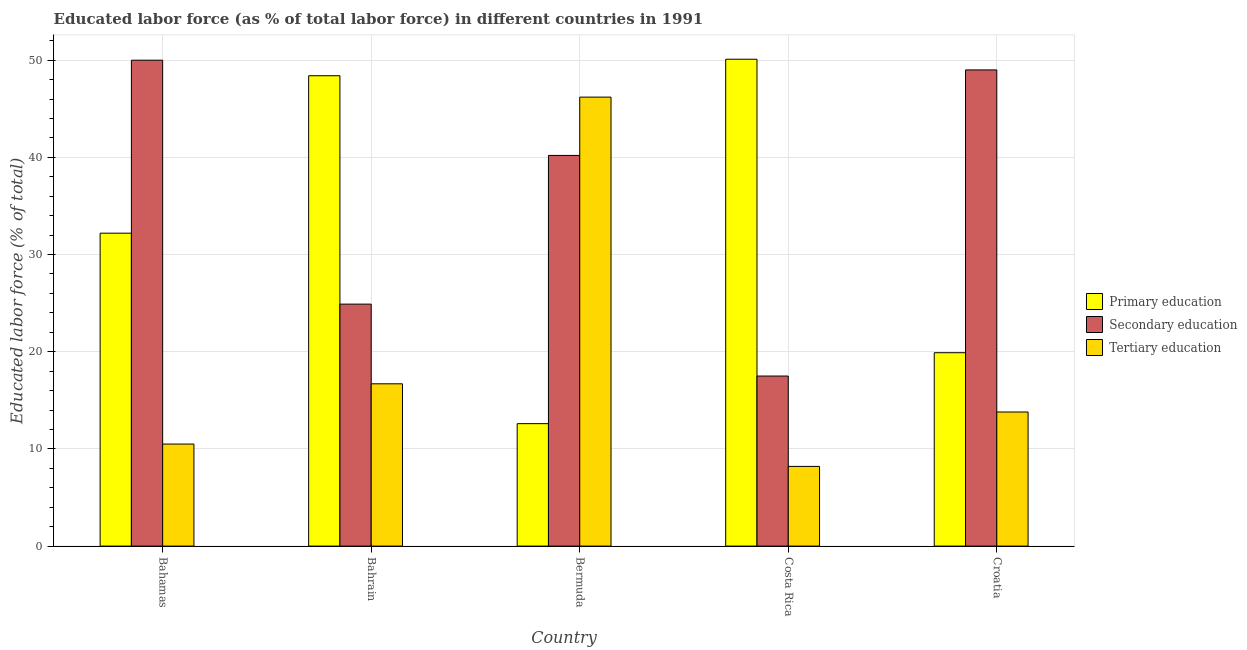How many groups of bars are there?
Ensure brevity in your answer.  5. Are the number of bars per tick equal to the number of legend labels?
Offer a very short reply. Yes. How many bars are there on the 1st tick from the left?
Offer a terse response. 3. What is the label of the 5th group of bars from the left?
Your answer should be compact. Croatia. In how many cases, is the number of bars for a given country not equal to the number of legend labels?
Make the answer very short. 0. What is the percentage of labor force who received primary education in Bahamas?
Your answer should be compact. 32.2. Across all countries, what is the maximum percentage of labor force who received primary education?
Provide a short and direct response. 50.1. Across all countries, what is the minimum percentage of labor force who received secondary education?
Keep it short and to the point. 17.5. In which country was the percentage of labor force who received tertiary education minimum?
Provide a succinct answer. Costa Rica. What is the total percentage of labor force who received secondary education in the graph?
Ensure brevity in your answer.  181.6. What is the difference between the percentage of labor force who received tertiary education in Bahamas and that in Bahrain?
Offer a very short reply. -6.2. What is the difference between the percentage of labor force who received secondary education in Croatia and the percentage of labor force who received primary education in Costa Rica?
Offer a very short reply. -1.1. What is the average percentage of labor force who received tertiary education per country?
Your answer should be compact. 19.08. What is the difference between the percentage of labor force who received tertiary education and percentage of labor force who received secondary education in Bahrain?
Your response must be concise. -8.2. In how many countries, is the percentage of labor force who received primary education greater than 18 %?
Your response must be concise. 4. What is the ratio of the percentage of labor force who received secondary education in Bermuda to that in Costa Rica?
Your response must be concise. 2.3. Is the percentage of labor force who received secondary education in Costa Rica less than that in Croatia?
Keep it short and to the point. Yes. What is the difference between the highest and the second highest percentage of labor force who received primary education?
Keep it short and to the point. 1.7. What is the difference between the highest and the lowest percentage of labor force who received primary education?
Provide a short and direct response. 37.5. In how many countries, is the percentage of labor force who received tertiary education greater than the average percentage of labor force who received tertiary education taken over all countries?
Your response must be concise. 1. Is the sum of the percentage of labor force who received tertiary education in Costa Rica and Croatia greater than the maximum percentage of labor force who received secondary education across all countries?
Offer a terse response. No. What does the 3rd bar from the left in Bermuda represents?
Your response must be concise. Tertiary education. What does the 3rd bar from the right in Bermuda represents?
Make the answer very short. Primary education. How many countries are there in the graph?
Give a very brief answer. 5. What is the difference between two consecutive major ticks on the Y-axis?
Give a very brief answer. 10. Does the graph contain any zero values?
Offer a terse response. No. Where does the legend appear in the graph?
Offer a very short reply. Center right. How many legend labels are there?
Your answer should be compact. 3. How are the legend labels stacked?
Provide a short and direct response. Vertical. What is the title of the graph?
Provide a succinct answer. Educated labor force (as % of total labor force) in different countries in 1991. What is the label or title of the X-axis?
Keep it short and to the point. Country. What is the label or title of the Y-axis?
Offer a very short reply. Educated labor force (% of total). What is the Educated labor force (% of total) in Primary education in Bahamas?
Keep it short and to the point. 32.2. What is the Educated labor force (% of total) of Tertiary education in Bahamas?
Make the answer very short. 10.5. What is the Educated labor force (% of total) of Primary education in Bahrain?
Provide a short and direct response. 48.4. What is the Educated labor force (% of total) of Secondary education in Bahrain?
Offer a very short reply. 24.9. What is the Educated labor force (% of total) in Tertiary education in Bahrain?
Ensure brevity in your answer.  16.7. What is the Educated labor force (% of total) of Primary education in Bermuda?
Provide a short and direct response. 12.6. What is the Educated labor force (% of total) of Secondary education in Bermuda?
Your answer should be compact. 40.2. What is the Educated labor force (% of total) of Tertiary education in Bermuda?
Provide a short and direct response. 46.2. What is the Educated labor force (% of total) of Primary education in Costa Rica?
Give a very brief answer. 50.1. What is the Educated labor force (% of total) in Secondary education in Costa Rica?
Provide a short and direct response. 17.5. What is the Educated labor force (% of total) in Tertiary education in Costa Rica?
Offer a very short reply. 8.2. What is the Educated labor force (% of total) in Primary education in Croatia?
Your answer should be very brief. 19.9. What is the Educated labor force (% of total) of Secondary education in Croatia?
Your answer should be very brief. 49. What is the Educated labor force (% of total) in Tertiary education in Croatia?
Provide a succinct answer. 13.8. Across all countries, what is the maximum Educated labor force (% of total) of Primary education?
Offer a terse response. 50.1. Across all countries, what is the maximum Educated labor force (% of total) in Tertiary education?
Make the answer very short. 46.2. Across all countries, what is the minimum Educated labor force (% of total) in Primary education?
Keep it short and to the point. 12.6. Across all countries, what is the minimum Educated labor force (% of total) of Tertiary education?
Your response must be concise. 8.2. What is the total Educated labor force (% of total) of Primary education in the graph?
Provide a succinct answer. 163.2. What is the total Educated labor force (% of total) of Secondary education in the graph?
Offer a very short reply. 181.6. What is the total Educated labor force (% of total) in Tertiary education in the graph?
Offer a very short reply. 95.4. What is the difference between the Educated labor force (% of total) in Primary education in Bahamas and that in Bahrain?
Keep it short and to the point. -16.2. What is the difference between the Educated labor force (% of total) of Secondary education in Bahamas and that in Bahrain?
Provide a short and direct response. 25.1. What is the difference between the Educated labor force (% of total) of Tertiary education in Bahamas and that in Bahrain?
Offer a terse response. -6.2. What is the difference between the Educated labor force (% of total) of Primary education in Bahamas and that in Bermuda?
Your answer should be very brief. 19.6. What is the difference between the Educated labor force (% of total) in Tertiary education in Bahamas and that in Bermuda?
Your answer should be very brief. -35.7. What is the difference between the Educated labor force (% of total) of Primary education in Bahamas and that in Costa Rica?
Provide a short and direct response. -17.9. What is the difference between the Educated labor force (% of total) of Secondary education in Bahamas and that in Costa Rica?
Your response must be concise. 32.5. What is the difference between the Educated labor force (% of total) of Tertiary education in Bahamas and that in Costa Rica?
Ensure brevity in your answer.  2.3. What is the difference between the Educated labor force (% of total) in Primary education in Bahamas and that in Croatia?
Your answer should be compact. 12.3. What is the difference between the Educated labor force (% of total) in Secondary education in Bahamas and that in Croatia?
Offer a terse response. 1. What is the difference between the Educated labor force (% of total) in Primary education in Bahrain and that in Bermuda?
Keep it short and to the point. 35.8. What is the difference between the Educated labor force (% of total) of Secondary education in Bahrain and that in Bermuda?
Make the answer very short. -15.3. What is the difference between the Educated labor force (% of total) in Tertiary education in Bahrain and that in Bermuda?
Offer a very short reply. -29.5. What is the difference between the Educated labor force (% of total) of Primary education in Bahrain and that in Costa Rica?
Your answer should be compact. -1.7. What is the difference between the Educated labor force (% of total) of Secondary education in Bahrain and that in Croatia?
Offer a very short reply. -24.1. What is the difference between the Educated labor force (% of total) of Primary education in Bermuda and that in Costa Rica?
Make the answer very short. -37.5. What is the difference between the Educated labor force (% of total) in Secondary education in Bermuda and that in Costa Rica?
Provide a short and direct response. 22.7. What is the difference between the Educated labor force (% of total) of Primary education in Bermuda and that in Croatia?
Your answer should be compact. -7.3. What is the difference between the Educated labor force (% of total) of Secondary education in Bermuda and that in Croatia?
Your answer should be very brief. -8.8. What is the difference between the Educated labor force (% of total) of Tertiary education in Bermuda and that in Croatia?
Provide a short and direct response. 32.4. What is the difference between the Educated labor force (% of total) in Primary education in Costa Rica and that in Croatia?
Your answer should be compact. 30.2. What is the difference between the Educated labor force (% of total) in Secondary education in Costa Rica and that in Croatia?
Ensure brevity in your answer.  -31.5. What is the difference between the Educated labor force (% of total) of Tertiary education in Costa Rica and that in Croatia?
Make the answer very short. -5.6. What is the difference between the Educated labor force (% of total) in Primary education in Bahamas and the Educated labor force (% of total) in Secondary education in Bahrain?
Provide a succinct answer. 7.3. What is the difference between the Educated labor force (% of total) in Secondary education in Bahamas and the Educated labor force (% of total) in Tertiary education in Bahrain?
Your answer should be very brief. 33.3. What is the difference between the Educated labor force (% of total) of Primary education in Bahamas and the Educated labor force (% of total) of Secondary education in Bermuda?
Make the answer very short. -8. What is the difference between the Educated labor force (% of total) in Primary education in Bahamas and the Educated labor force (% of total) in Tertiary education in Bermuda?
Ensure brevity in your answer.  -14. What is the difference between the Educated labor force (% of total) of Secondary education in Bahamas and the Educated labor force (% of total) of Tertiary education in Bermuda?
Provide a succinct answer. 3.8. What is the difference between the Educated labor force (% of total) in Secondary education in Bahamas and the Educated labor force (% of total) in Tertiary education in Costa Rica?
Make the answer very short. 41.8. What is the difference between the Educated labor force (% of total) of Primary education in Bahamas and the Educated labor force (% of total) of Secondary education in Croatia?
Give a very brief answer. -16.8. What is the difference between the Educated labor force (% of total) of Primary education in Bahamas and the Educated labor force (% of total) of Tertiary education in Croatia?
Offer a very short reply. 18.4. What is the difference between the Educated labor force (% of total) of Secondary education in Bahamas and the Educated labor force (% of total) of Tertiary education in Croatia?
Ensure brevity in your answer.  36.2. What is the difference between the Educated labor force (% of total) of Secondary education in Bahrain and the Educated labor force (% of total) of Tertiary education in Bermuda?
Provide a short and direct response. -21.3. What is the difference between the Educated labor force (% of total) in Primary education in Bahrain and the Educated labor force (% of total) in Secondary education in Costa Rica?
Give a very brief answer. 30.9. What is the difference between the Educated labor force (% of total) of Primary education in Bahrain and the Educated labor force (% of total) of Tertiary education in Costa Rica?
Ensure brevity in your answer.  40.2. What is the difference between the Educated labor force (% of total) in Secondary education in Bahrain and the Educated labor force (% of total) in Tertiary education in Costa Rica?
Make the answer very short. 16.7. What is the difference between the Educated labor force (% of total) in Primary education in Bahrain and the Educated labor force (% of total) in Tertiary education in Croatia?
Your response must be concise. 34.6. What is the difference between the Educated labor force (% of total) in Secondary education in Bahrain and the Educated labor force (% of total) in Tertiary education in Croatia?
Ensure brevity in your answer.  11.1. What is the difference between the Educated labor force (% of total) in Primary education in Bermuda and the Educated labor force (% of total) in Tertiary education in Costa Rica?
Give a very brief answer. 4.4. What is the difference between the Educated labor force (% of total) of Primary education in Bermuda and the Educated labor force (% of total) of Secondary education in Croatia?
Keep it short and to the point. -36.4. What is the difference between the Educated labor force (% of total) in Primary education in Bermuda and the Educated labor force (% of total) in Tertiary education in Croatia?
Ensure brevity in your answer.  -1.2. What is the difference between the Educated labor force (% of total) of Secondary education in Bermuda and the Educated labor force (% of total) of Tertiary education in Croatia?
Make the answer very short. 26.4. What is the difference between the Educated labor force (% of total) in Primary education in Costa Rica and the Educated labor force (% of total) in Secondary education in Croatia?
Give a very brief answer. 1.1. What is the difference between the Educated labor force (% of total) in Primary education in Costa Rica and the Educated labor force (% of total) in Tertiary education in Croatia?
Provide a short and direct response. 36.3. What is the average Educated labor force (% of total) of Primary education per country?
Give a very brief answer. 32.64. What is the average Educated labor force (% of total) of Secondary education per country?
Your answer should be very brief. 36.32. What is the average Educated labor force (% of total) in Tertiary education per country?
Make the answer very short. 19.08. What is the difference between the Educated labor force (% of total) in Primary education and Educated labor force (% of total) in Secondary education in Bahamas?
Your answer should be compact. -17.8. What is the difference between the Educated labor force (% of total) of Primary education and Educated labor force (% of total) of Tertiary education in Bahamas?
Offer a terse response. 21.7. What is the difference between the Educated labor force (% of total) of Secondary education and Educated labor force (% of total) of Tertiary education in Bahamas?
Offer a terse response. 39.5. What is the difference between the Educated labor force (% of total) of Primary education and Educated labor force (% of total) of Tertiary education in Bahrain?
Give a very brief answer. 31.7. What is the difference between the Educated labor force (% of total) in Primary education and Educated labor force (% of total) in Secondary education in Bermuda?
Your answer should be compact. -27.6. What is the difference between the Educated labor force (% of total) of Primary education and Educated labor force (% of total) of Tertiary education in Bermuda?
Offer a terse response. -33.6. What is the difference between the Educated labor force (% of total) in Primary education and Educated labor force (% of total) in Secondary education in Costa Rica?
Offer a very short reply. 32.6. What is the difference between the Educated labor force (% of total) of Primary education and Educated labor force (% of total) of Tertiary education in Costa Rica?
Provide a succinct answer. 41.9. What is the difference between the Educated labor force (% of total) of Secondary education and Educated labor force (% of total) of Tertiary education in Costa Rica?
Give a very brief answer. 9.3. What is the difference between the Educated labor force (% of total) of Primary education and Educated labor force (% of total) of Secondary education in Croatia?
Make the answer very short. -29.1. What is the difference between the Educated labor force (% of total) in Primary education and Educated labor force (% of total) in Tertiary education in Croatia?
Give a very brief answer. 6.1. What is the difference between the Educated labor force (% of total) in Secondary education and Educated labor force (% of total) in Tertiary education in Croatia?
Keep it short and to the point. 35.2. What is the ratio of the Educated labor force (% of total) of Primary education in Bahamas to that in Bahrain?
Give a very brief answer. 0.67. What is the ratio of the Educated labor force (% of total) in Secondary education in Bahamas to that in Bahrain?
Give a very brief answer. 2.01. What is the ratio of the Educated labor force (% of total) of Tertiary education in Bahamas to that in Bahrain?
Your answer should be compact. 0.63. What is the ratio of the Educated labor force (% of total) of Primary education in Bahamas to that in Bermuda?
Your answer should be compact. 2.56. What is the ratio of the Educated labor force (% of total) of Secondary education in Bahamas to that in Bermuda?
Keep it short and to the point. 1.24. What is the ratio of the Educated labor force (% of total) in Tertiary education in Bahamas to that in Bermuda?
Make the answer very short. 0.23. What is the ratio of the Educated labor force (% of total) of Primary education in Bahamas to that in Costa Rica?
Provide a short and direct response. 0.64. What is the ratio of the Educated labor force (% of total) of Secondary education in Bahamas to that in Costa Rica?
Your answer should be compact. 2.86. What is the ratio of the Educated labor force (% of total) of Tertiary education in Bahamas to that in Costa Rica?
Keep it short and to the point. 1.28. What is the ratio of the Educated labor force (% of total) of Primary education in Bahamas to that in Croatia?
Provide a succinct answer. 1.62. What is the ratio of the Educated labor force (% of total) in Secondary education in Bahamas to that in Croatia?
Give a very brief answer. 1.02. What is the ratio of the Educated labor force (% of total) of Tertiary education in Bahamas to that in Croatia?
Offer a terse response. 0.76. What is the ratio of the Educated labor force (% of total) of Primary education in Bahrain to that in Bermuda?
Ensure brevity in your answer.  3.84. What is the ratio of the Educated labor force (% of total) in Secondary education in Bahrain to that in Bermuda?
Your response must be concise. 0.62. What is the ratio of the Educated labor force (% of total) in Tertiary education in Bahrain to that in Bermuda?
Your answer should be compact. 0.36. What is the ratio of the Educated labor force (% of total) of Primary education in Bahrain to that in Costa Rica?
Your response must be concise. 0.97. What is the ratio of the Educated labor force (% of total) in Secondary education in Bahrain to that in Costa Rica?
Make the answer very short. 1.42. What is the ratio of the Educated labor force (% of total) in Tertiary education in Bahrain to that in Costa Rica?
Your answer should be compact. 2.04. What is the ratio of the Educated labor force (% of total) of Primary education in Bahrain to that in Croatia?
Keep it short and to the point. 2.43. What is the ratio of the Educated labor force (% of total) in Secondary education in Bahrain to that in Croatia?
Provide a short and direct response. 0.51. What is the ratio of the Educated labor force (% of total) of Tertiary education in Bahrain to that in Croatia?
Keep it short and to the point. 1.21. What is the ratio of the Educated labor force (% of total) of Primary education in Bermuda to that in Costa Rica?
Keep it short and to the point. 0.25. What is the ratio of the Educated labor force (% of total) of Secondary education in Bermuda to that in Costa Rica?
Your answer should be compact. 2.3. What is the ratio of the Educated labor force (% of total) in Tertiary education in Bermuda to that in Costa Rica?
Your answer should be compact. 5.63. What is the ratio of the Educated labor force (% of total) of Primary education in Bermuda to that in Croatia?
Make the answer very short. 0.63. What is the ratio of the Educated labor force (% of total) of Secondary education in Bermuda to that in Croatia?
Give a very brief answer. 0.82. What is the ratio of the Educated labor force (% of total) of Tertiary education in Bermuda to that in Croatia?
Offer a terse response. 3.35. What is the ratio of the Educated labor force (% of total) in Primary education in Costa Rica to that in Croatia?
Provide a short and direct response. 2.52. What is the ratio of the Educated labor force (% of total) of Secondary education in Costa Rica to that in Croatia?
Offer a very short reply. 0.36. What is the ratio of the Educated labor force (% of total) of Tertiary education in Costa Rica to that in Croatia?
Provide a succinct answer. 0.59. What is the difference between the highest and the second highest Educated labor force (% of total) in Primary education?
Keep it short and to the point. 1.7. What is the difference between the highest and the second highest Educated labor force (% of total) of Secondary education?
Give a very brief answer. 1. What is the difference between the highest and the second highest Educated labor force (% of total) in Tertiary education?
Provide a short and direct response. 29.5. What is the difference between the highest and the lowest Educated labor force (% of total) of Primary education?
Give a very brief answer. 37.5. What is the difference between the highest and the lowest Educated labor force (% of total) of Secondary education?
Your answer should be compact. 32.5. What is the difference between the highest and the lowest Educated labor force (% of total) in Tertiary education?
Give a very brief answer. 38. 